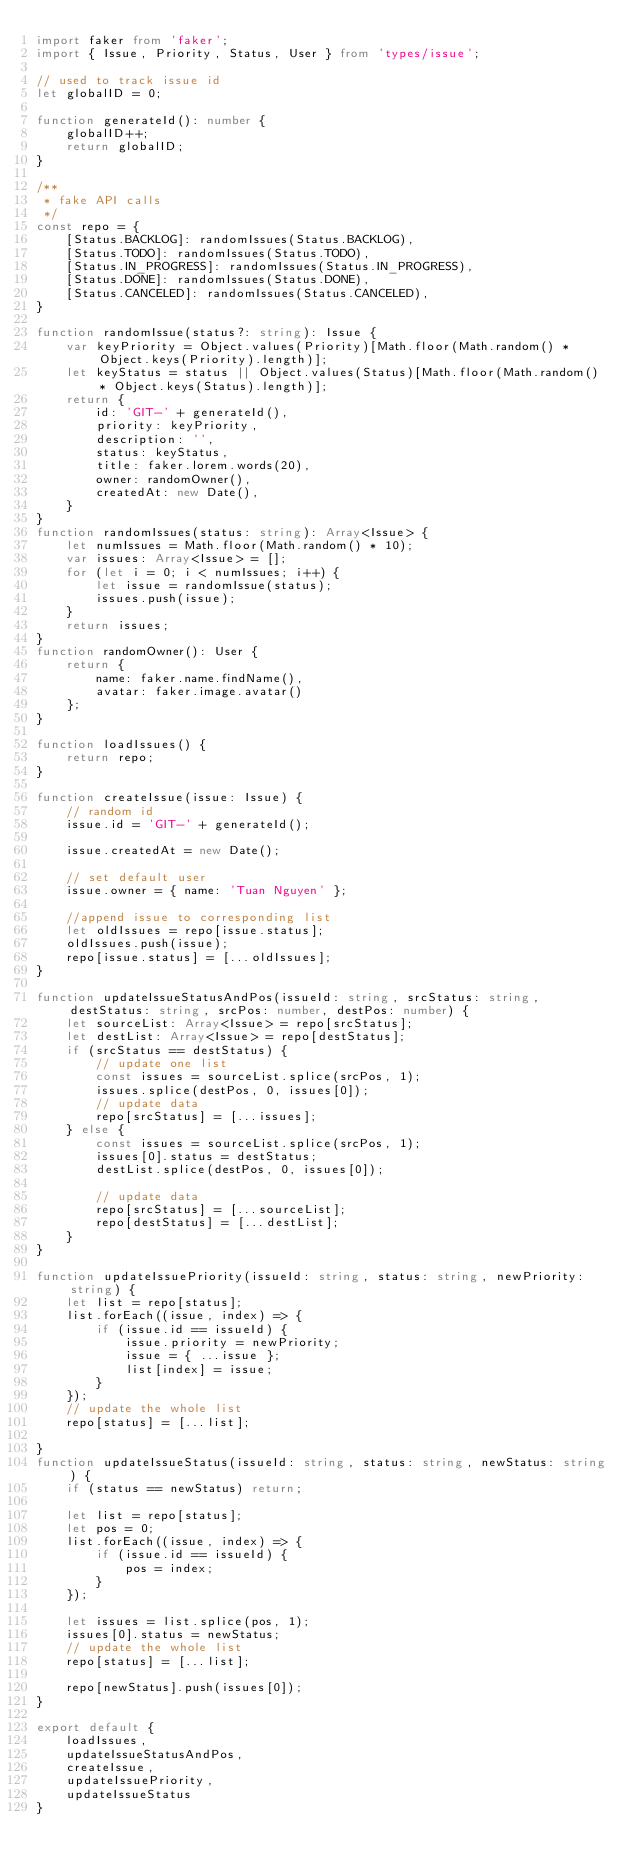<code> <loc_0><loc_0><loc_500><loc_500><_TypeScript_>import faker from 'faker';
import { Issue, Priority, Status, User } from 'types/issue';

// used to track issue id
let globalID = 0;

function generateId(): number {
    globalID++;
    return globalID;
}

/**
 * fake API calls
 */
const repo = {
    [Status.BACKLOG]: randomIssues(Status.BACKLOG),
    [Status.TODO]: randomIssues(Status.TODO),
    [Status.IN_PROGRESS]: randomIssues(Status.IN_PROGRESS),
    [Status.DONE]: randomIssues(Status.DONE),
    [Status.CANCELED]: randomIssues(Status.CANCELED),
}

function randomIssue(status?: string): Issue {
    var keyPriority = Object.values(Priority)[Math.floor(Math.random() * Object.keys(Priority).length)];
    let keyStatus = status || Object.values(Status)[Math.floor(Math.random() * Object.keys(Status).length)];
    return {
        id: 'GIT-' + generateId(),
        priority: keyPriority,
        description: '',
        status: keyStatus,
        title: faker.lorem.words(20),
        owner: randomOwner(),
        createdAt: new Date(),
    }
}
function randomIssues(status: string): Array<Issue> {
    let numIssues = Math.floor(Math.random() * 10);
    var issues: Array<Issue> = [];
    for (let i = 0; i < numIssues; i++) {
        let issue = randomIssue(status);
        issues.push(issue);
    }
    return issues;
}
function randomOwner(): User {
    return {
        name: faker.name.findName(),
        avatar: faker.image.avatar()
    };
}

function loadIssues() {
    return repo;
}

function createIssue(issue: Issue) {
    // random id
    issue.id = 'GIT-' + generateId();

    issue.createdAt = new Date();

    // set default user
    issue.owner = { name: 'Tuan Nguyen' };

    //append issue to corresponding list
    let oldIssues = repo[issue.status];
    oldIssues.push(issue);
    repo[issue.status] = [...oldIssues];
}

function updateIssueStatusAndPos(issueId: string, srcStatus: string, destStatus: string, srcPos: number, destPos: number) {
    let sourceList: Array<Issue> = repo[srcStatus];
    let destList: Array<Issue> = repo[destStatus];
    if (srcStatus == destStatus) {
        // update one list
        const issues = sourceList.splice(srcPos, 1);
        issues.splice(destPos, 0, issues[0]);
        // update data
        repo[srcStatus] = [...issues];
    } else {
        const issues = sourceList.splice(srcPos, 1);
        issues[0].status = destStatus;
        destList.splice(destPos, 0, issues[0]);

        // update data
        repo[srcStatus] = [...sourceList];
        repo[destStatus] = [...destList];
    }
}

function updateIssuePriority(issueId: string, status: string, newPriority: string) {
    let list = repo[status];
    list.forEach((issue, index) => {
        if (issue.id == issueId) {
            issue.priority = newPriority;
            issue = { ...issue };
            list[index] = issue;
        }
    });
    // update the whole list
    repo[status] = [...list];

}
function updateIssueStatus(issueId: string, status: string, newStatus: string) {
    if (status == newStatus) return;

    let list = repo[status];
    let pos = 0;
    list.forEach((issue, index) => {
        if (issue.id == issueId) {
            pos = index;
        }
    });

    let issues = list.splice(pos, 1);
    issues[0].status = newStatus;
    // update the whole list
    repo[status] = [...list];

    repo[newStatus].push(issues[0]);
}

export default {
    loadIssues,
    updateIssueStatusAndPos,
    createIssue,
    updateIssuePriority,
    updateIssueStatus
}</code> 